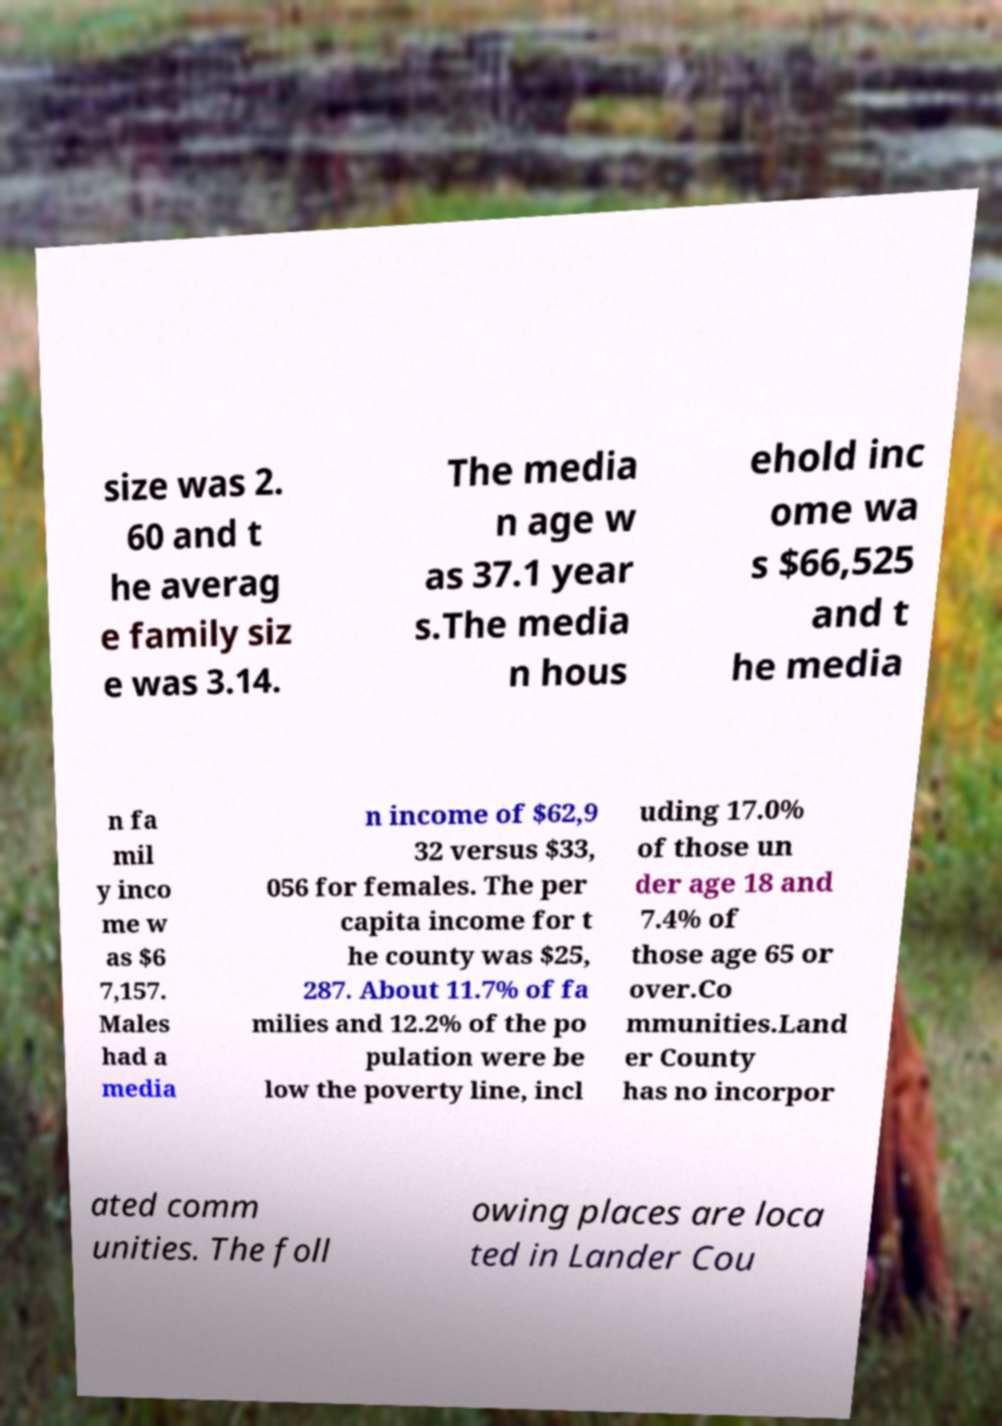Please identify and transcribe the text found in this image. size was 2. 60 and t he averag e family siz e was 3.14. The media n age w as 37.1 year s.The media n hous ehold inc ome wa s $66,525 and t he media n fa mil y inco me w as $6 7,157. Males had a media n income of $62,9 32 versus $33, 056 for females. The per capita income for t he county was $25, 287. About 11.7% of fa milies and 12.2% of the po pulation were be low the poverty line, incl uding 17.0% of those un der age 18 and 7.4% of those age 65 or over.Co mmunities.Land er County has no incorpor ated comm unities. The foll owing places are loca ted in Lander Cou 